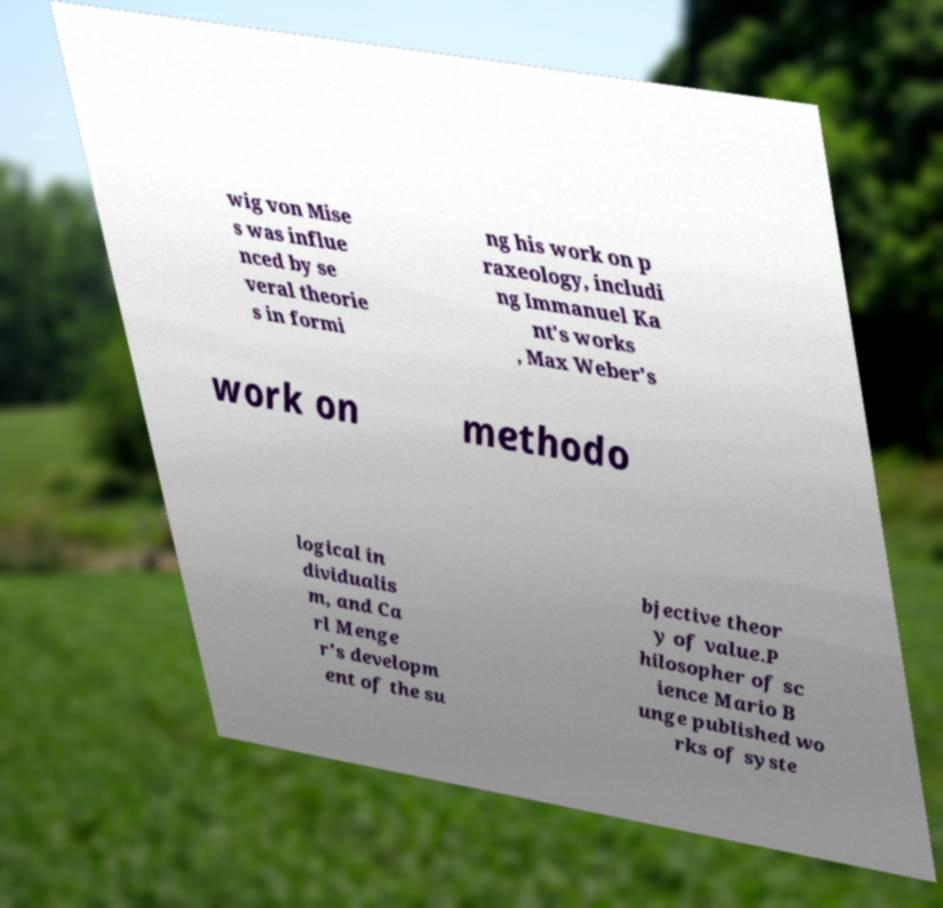Can you accurately transcribe the text from the provided image for me? wig von Mise s was influe nced by se veral theorie s in formi ng his work on p raxeology, includi ng Immanuel Ka nt's works , Max Weber's work on methodo logical in dividualis m, and Ca rl Menge r's developm ent of the su bjective theor y of value.P hilosopher of sc ience Mario B unge published wo rks of syste 